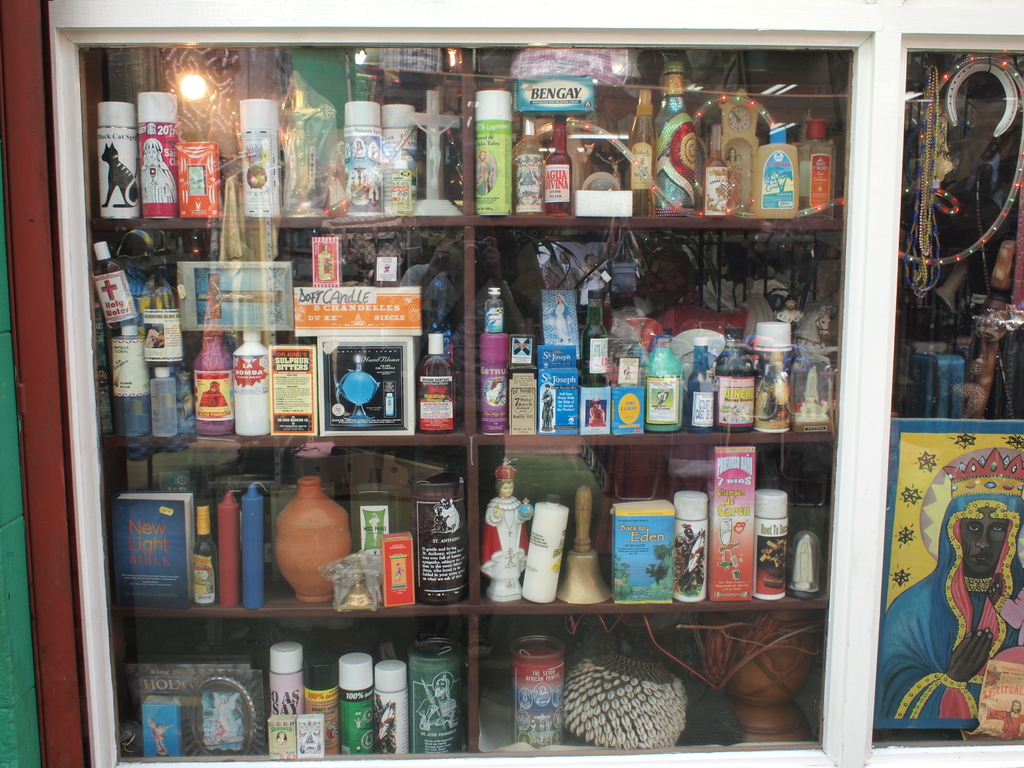Provide a one-sentence caption for the provided image. A diverse collection of cultural, religious, and vintage items displayed behind a glass window, including candles, religious figurines, and various bottled products. 